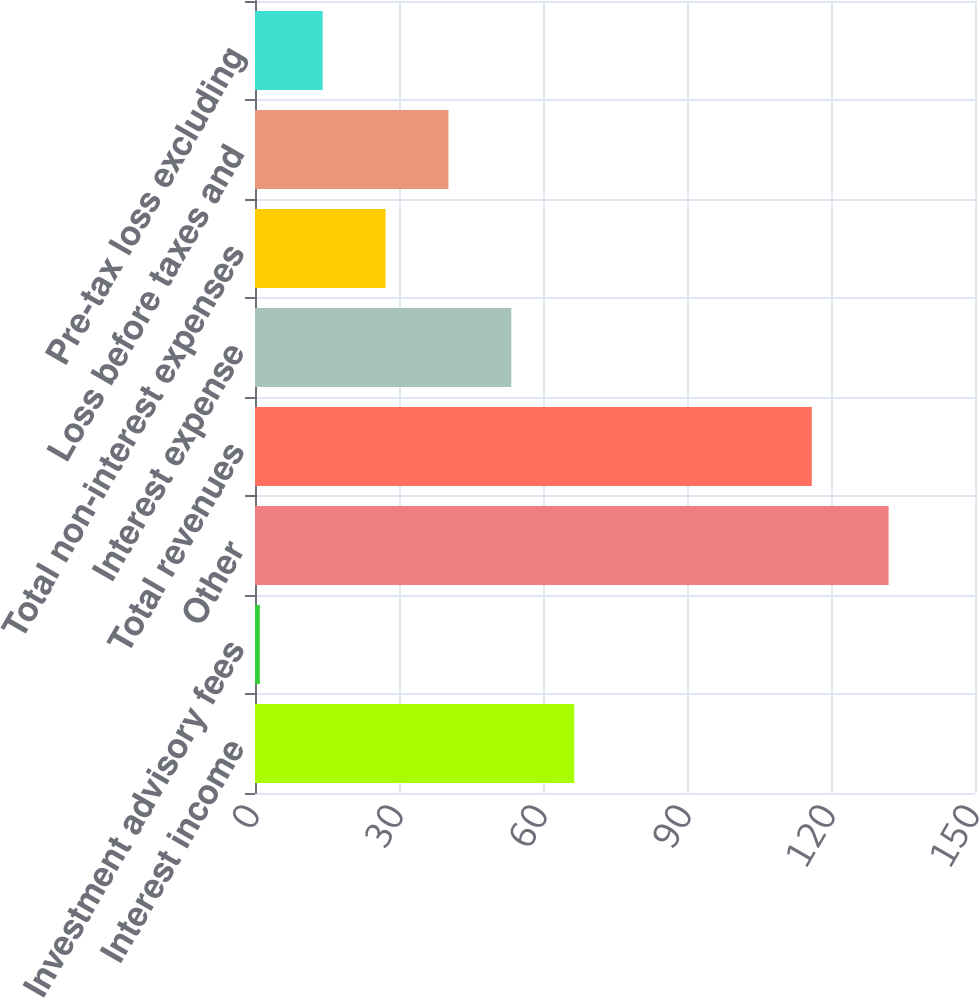Convert chart to OTSL. <chart><loc_0><loc_0><loc_500><loc_500><bar_chart><fcel>Interest income<fcel>Investment advisory fees<fcel>Other<fcel>Total revenues<fcel>Interest expense<fcel>Total non-interest expenses<fcel>Loss before taxes and<fcel>Pre-tax loss excluding<nl><fcel>66.5<fcel>1<fcel>132<fcel>116<fcel>53.4<fcel>27.2<fcel>40.3<fcel>14.1<nl></chart> 